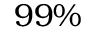<formula> <loc_0><loc_0><loc_500><loc_500>9 9 \%</formula> 